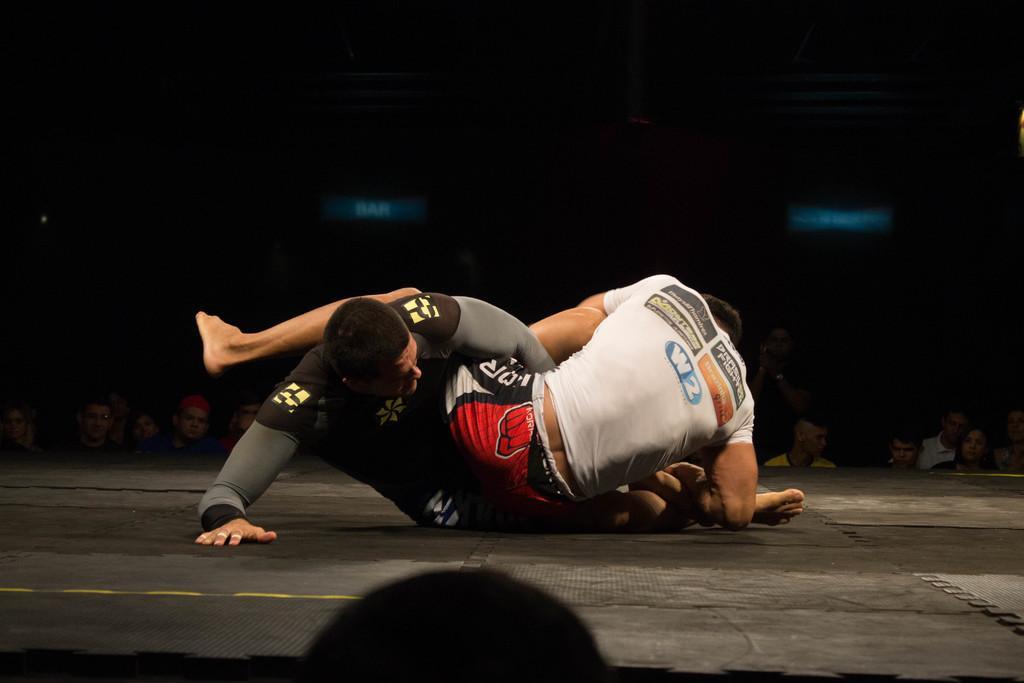Could you give a brief overview of what you see in this image? In the middle 2 men are wrestling, this person wore a white color t-shirt and this person wore a black color t-shirt. 